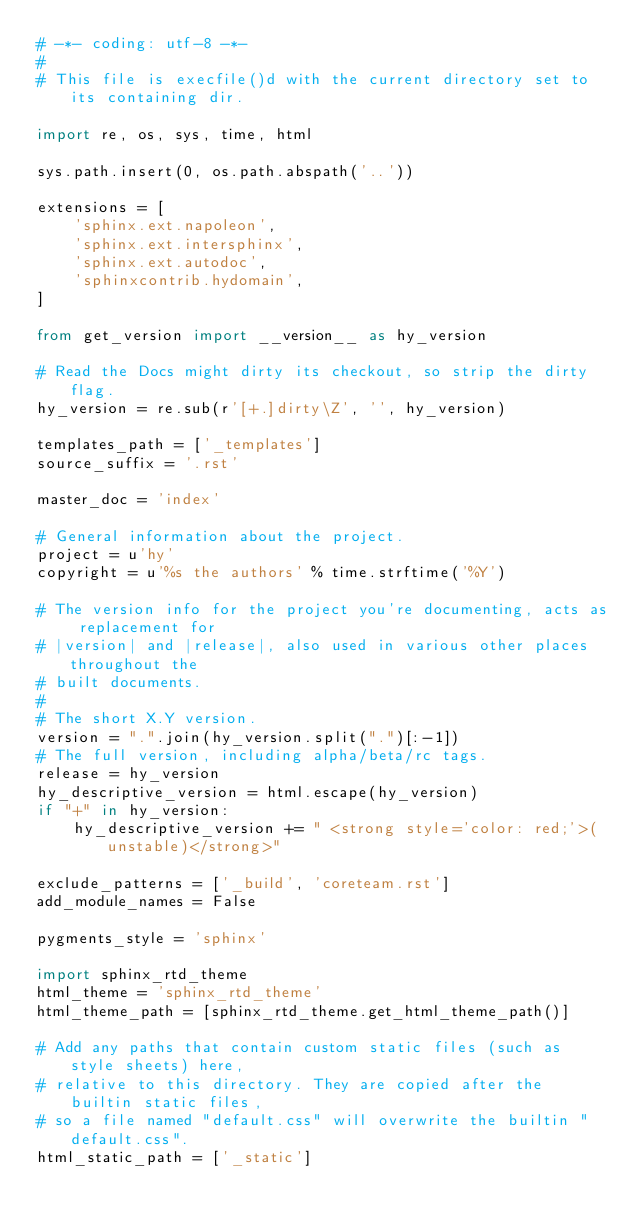<code> <loc_0><loc_0><loc_500><loc_500><_Python_># -*- coding: utf-8 -*-
#
# This file is execfile()d with the current directory set to its containing dir.

import re, os, sys, time, html

sys.path.insert(0, os.path.abspath('..'))

extensions = [
    'sphinx.ext.napoleon',
    'sphinx.ext.intersphinx',
    'sphinx.ext.autodoc',
    'sphinxcontrib.hydomain',
]

from get_version import __version__ as hy_version

# Read the Docs might dirty its checkout, so strip the dirty flag.
hy_version = re.sub(r'[+.]dirty\Z', '', hy_version)

templates_path = ['_templates']
source_suffix = '.rst'

master_doc = 'index'

# General information about the project.
project = u'hy'
copyright = u'%s the authors' % time.strftime('%Y')

# The version info for the project you're documenting, acts as replacement for
# |version| and |release|, also used in various other places throughout the
# built documents.
#
# The short X.Y version.
version = ".".join(hy_version.split(".")[:-1])
# The full version, including alpha/beta/rc tags.
release = hy_version
hy_descriptive_version = html.escape(hy_version)
if "+" in hy_version:
    hy_descriptive_version += " <strong style='color: red;'>(unstable)</strong>"

exclude_patterns = ['_build', 'coreteam.rst']
add_module_names = False

pygments_style = 'sphinx'

import sphinx_rtd_theme
html_theme = 'sphinx_rtd_theme'
html_theme_path = [sphinx_rtd_theme.get_html_theme_path()]

# Add any paths that contain custom static files (such as style sheets) here,
# relative to this directory. They are copied after the builtin static files,
# so a file named "default.css" will overwrite the builtin "default.css".
html_static_path = ['_static']
</code> 